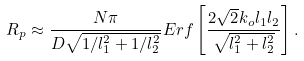Convert formula to latex. <formula><loc_0><loc_0><loc_500><loc_500>R _ { p } \approx \frac { N \pi } { D \sqrt { 1 / l _ { 1 } ^ { 2 } + 1 / l _ { 2 } ^ { 2 } } } E r f \left [ \frac { 2 \sqrt { 2 } k _ { o } l _ { 1 } l _ { 2 } } { \sqrt { l _ { 1 } ^ { 2 } + l _ { 2 } ^ { 2 } } } \right ] .</formula> 